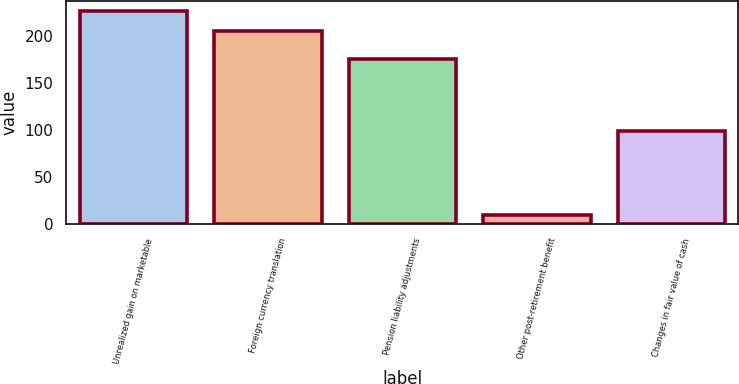Convert chart to OTSL. <chart><loc_0><loc_0><loc_500><loc_500><bar_chart><fcel>Unrealized gain on marketable<fcel>Foreign currency translation<fcel>Pension liability adjustments<fcel>Other post-retirement benefit<fcel>Changes in fair value of cash<nl><fcel>226.8<fcel>206<fcel>176<fcel>10<fcel>99<nl></chart> 